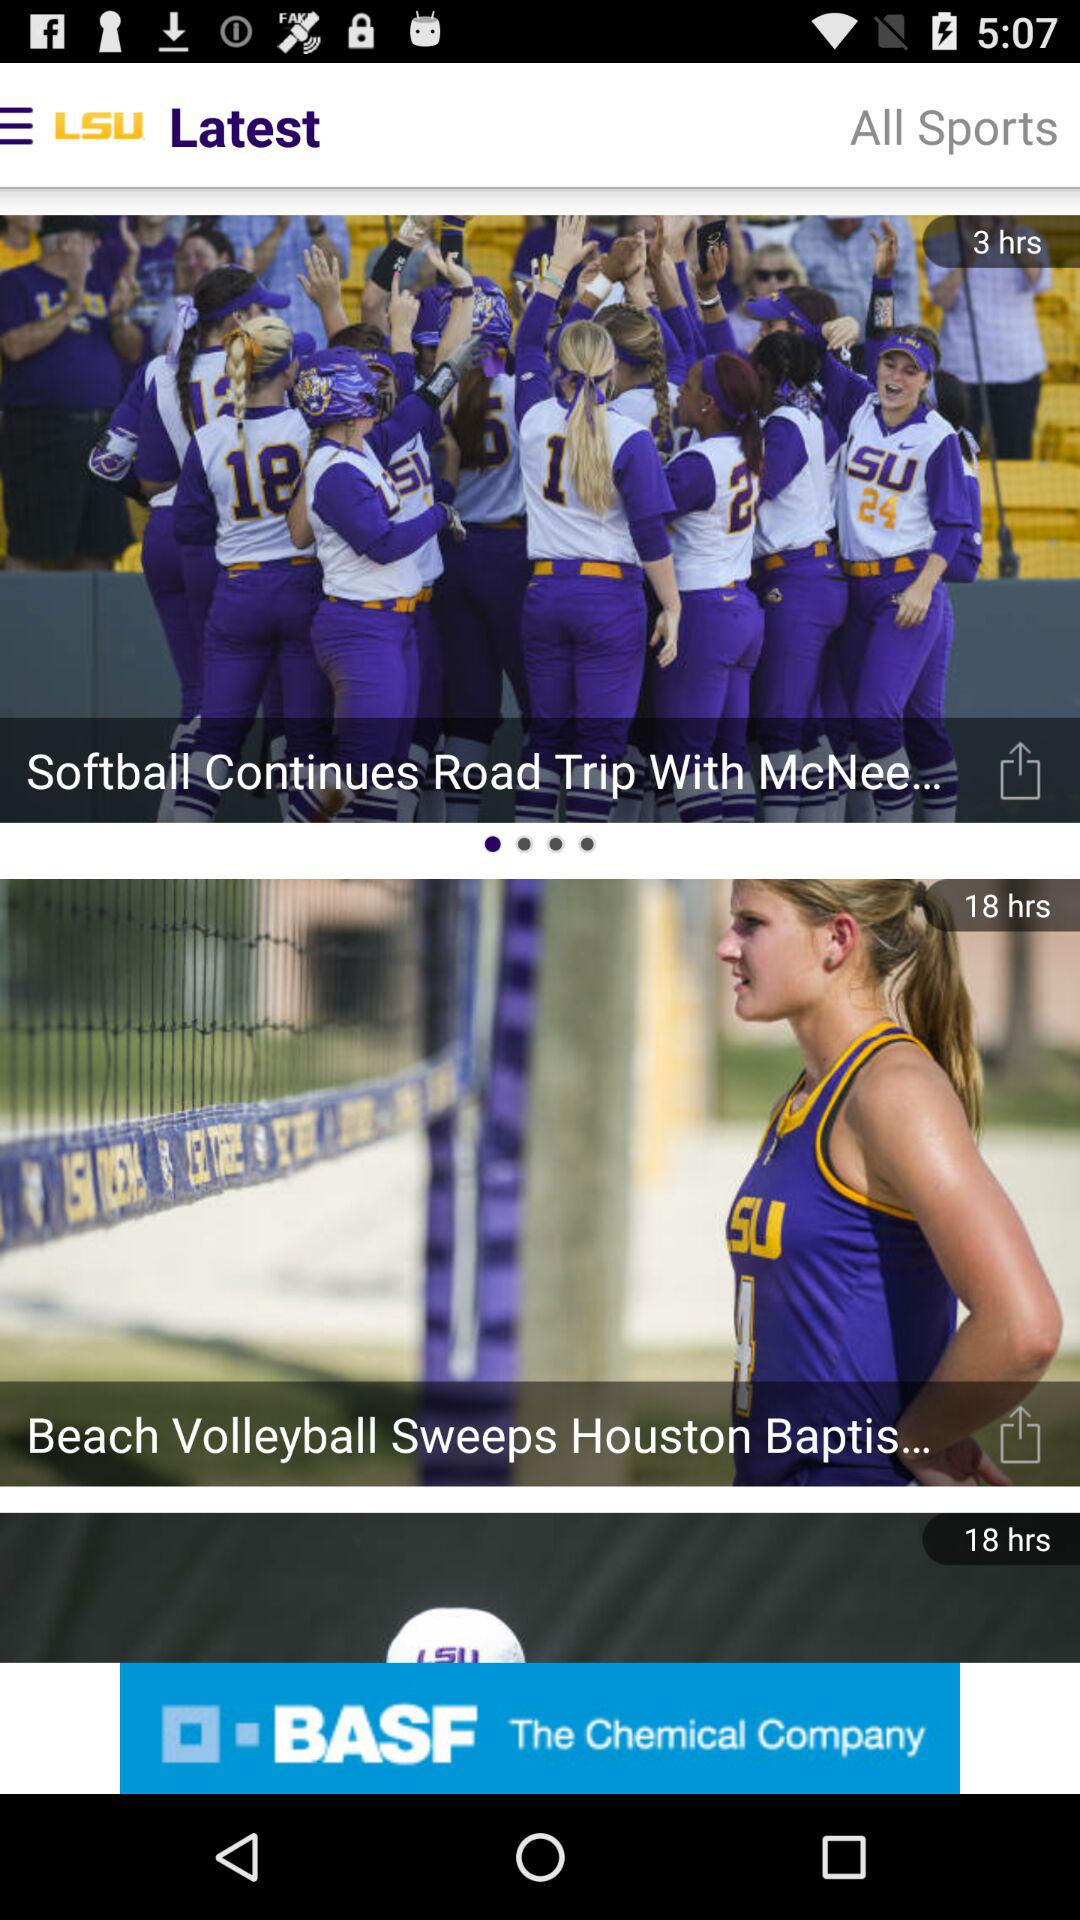How many hours apart are the two latest stories?
Answer the question using a single word or phrase. 15 